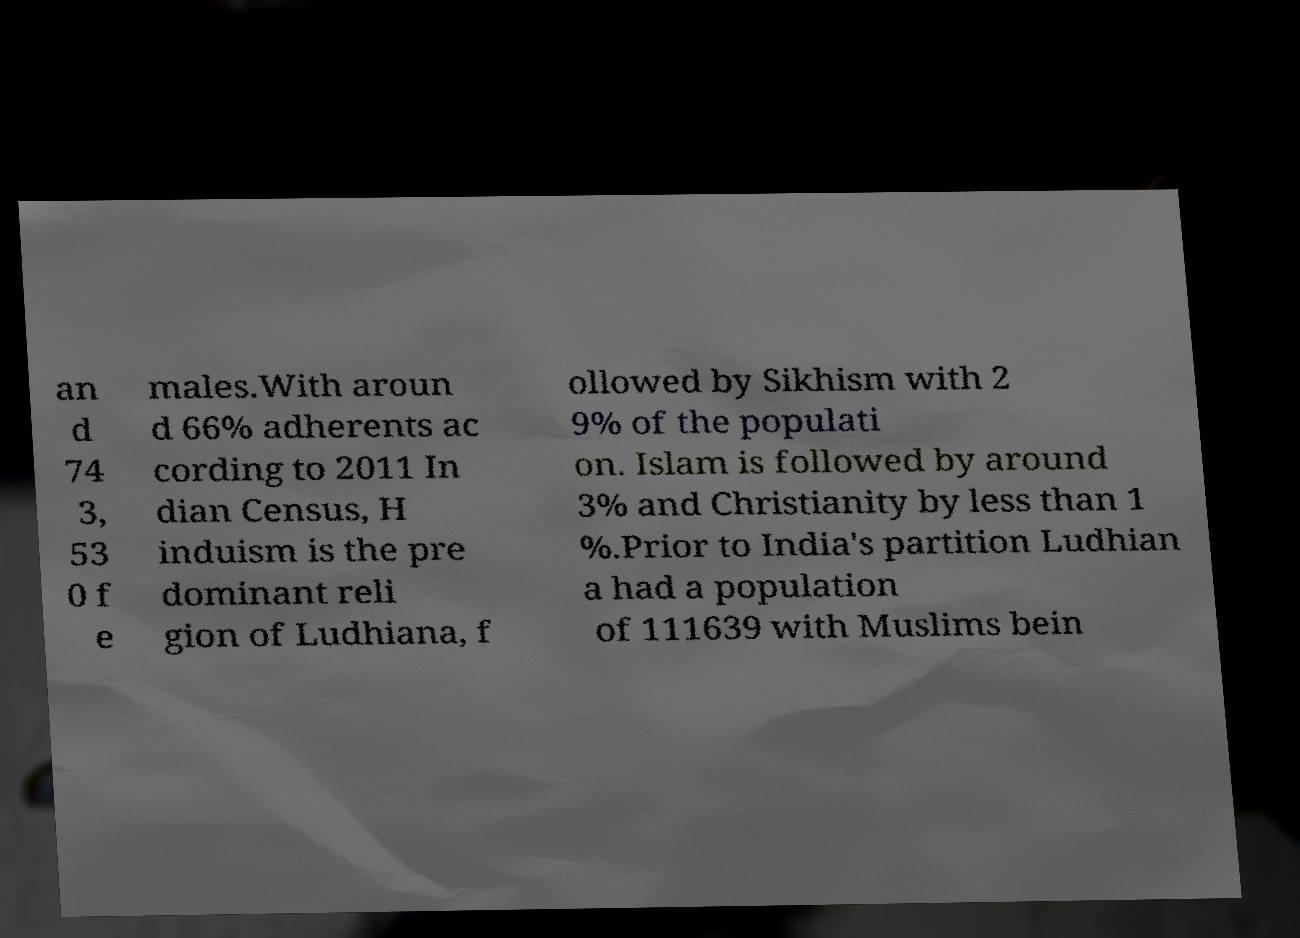There's text embedded in this image that I need extracted. Can you transcribe it verbatim? an d 74 3, 53 0 f e males.With aroun d 66% adherents ac cording to 2011 In dian Census, H induism is the pre dominant reli gion of Ludhiana, f ollowed by Sikhism with 2 9% of the populati on. Islam is followed by around 3% and Christianity by less than 1 %.Prior to India's partition Ludhian a had a population of 111639 with Muslims bein 